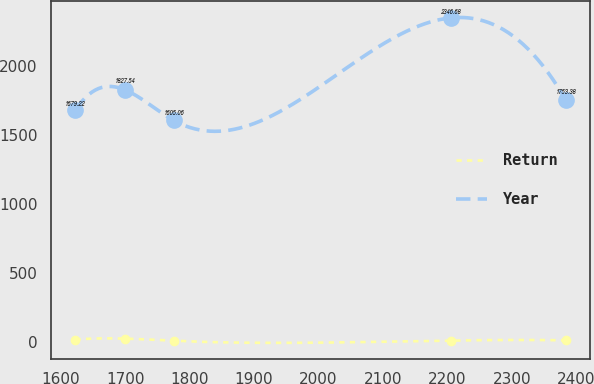Convert chart. <chart><loc_0><loc_0><loc_500><loc_500><line_chart><ecel><fcel>Return<fcel>Year<nl><fcel>1623.02<fcel>20<fcel>1679.22<nl><fcel>1699.04<fcel>26.81<fcel>1827.54<nl><fcel>1775.06<fcel>11.34<fcel>1605.06<nl><fcel>2205.47<fcel>12.89<fcel>2346.68<nl><fcel>2383.2<fcel>14.44<fcel>1753.38<nl></chart> 